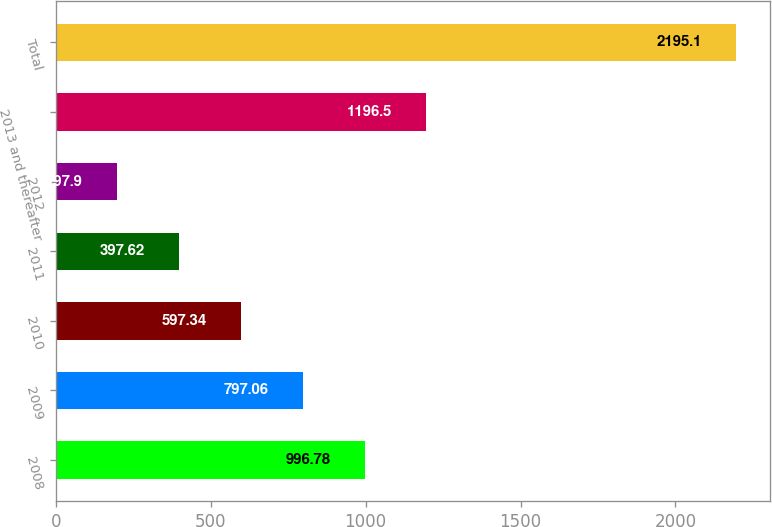<chart> <loc_0><loc_0><loc_500><loc_500><bar_chart><fcel>2008<fcel>2009<fcel>2010<fcel>2011<fcel>2012<fcel>2013 and thereafter<fcel>Total<nl><fcel>996.78<fcel>797.06<fcel>597.34<fcel>397.62<fcel>197.9<fcel>1196.5<fcel>2195.1<nl></chart> 